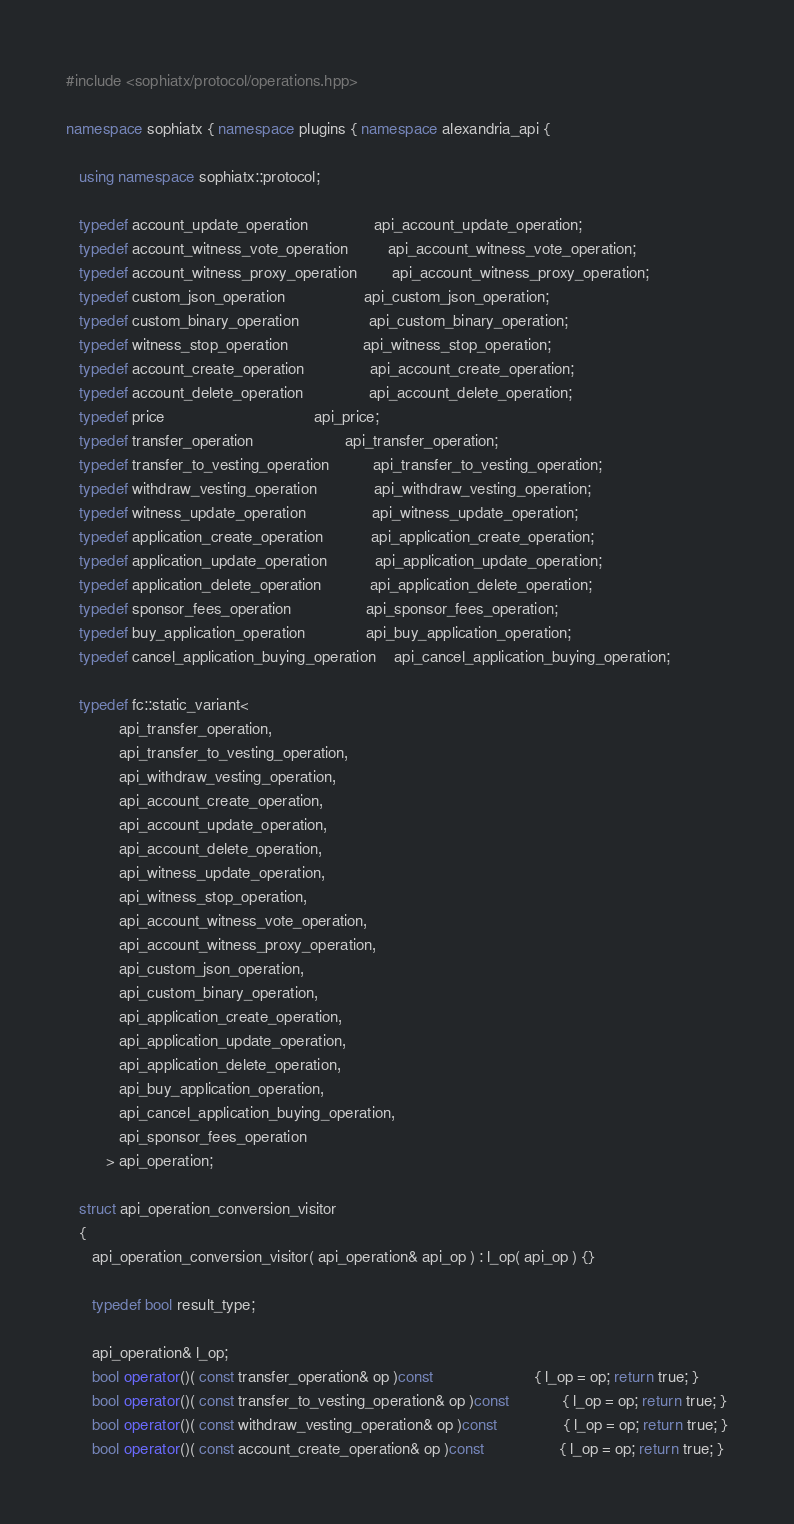Convert code to text. <code><loc_0><loc_0><loc_500><loc_500><_C++_>#include <sophiatx/protocol/operations.hpp>

namespace sophiatx { namespace plugins { namespace alexandria_api {

   using namespace sophiatx::protocol;

   typedef account_update_operation               api_account_update_operation;
   typedef account_witness_vote_operation         api_account_witness_vote_operation;
   typedef account_witness_proxy_operation        api_account_witness_proxy_operation;
   typedef custom_json_operation                  api_custom_json_operation;
   typedef custom_binary_operation                api_custom_binary_operation;
   typedef witness_stop_operation                 api_witness_stop_operation;
   typedef account_create_operation               api_account_create_operation;
   typedef account_delete_operation               api_account_delete_operation;
   typedef price                                  api_price;
   typedef transfer_operation                     api_transfer_operation;
   typedef transfer_to_vesting_operation          api_transfer_to_vesting_operation;
   typedef withdraw_vesting_operation             api_withdraw_vesting_operation;
   typedef witness_update_operation               api_witness_update_operation;
   typedef application_create_operation           api_application_create_operation;
   typedef application_update_operation           api_application_update_operation;
   typedef application_delete_operation           api_application_delete_operation;
   typedef sponsor_fees_operation                 api_sponsor_fees_operation;
   typedef buy_application_operation              api_buy_application_operation;
   typedef cancel_application_buying_operation    api_cancel_application_buying_operation;

   typedef fc::static_variant<
            api_transfer_operation,
            api_transfer_to_vesting_operation,
            api_withdraw_vesting_operation,
            api_account_create_operation,
            api_account_update_operation,
            api_account_delete_operation,
            api_witness_update_operation,
            api_witness_stop_operation,
            api_account_witness_vote_operation,
            api_account_witness_proxy_operation,
            api_custom_json_operation,
            api_custom_binary_operation,
            api_application_create_operation,
            api_application_update_operation,
            api_application_delete_operation,
            api_buy_application_operation,
            api_cancel_application_buying_operation,
            api_sponsor_fees_operation
         > api_operation;

   struct api_operation_conversion_visitor
   {
      api_operation_conversion_visitor( api_operation& api_op ) : l_op( api_op ) {}

      typedef bool result_type;

      api_operation& l_op;
      bool operator()( const transfer_operation& op )const                       { l_op = op; return true; }
      bool operator()( const transfer_to_vesting_operation& op )const            { l_op = op; return true; }
      bool operator()( const withdraw_vesting_operation& op )const               { l_op = op; return true; }
      bool operator()( const account_create_operation& op )const                 { l_op = op; return true; }</code> 